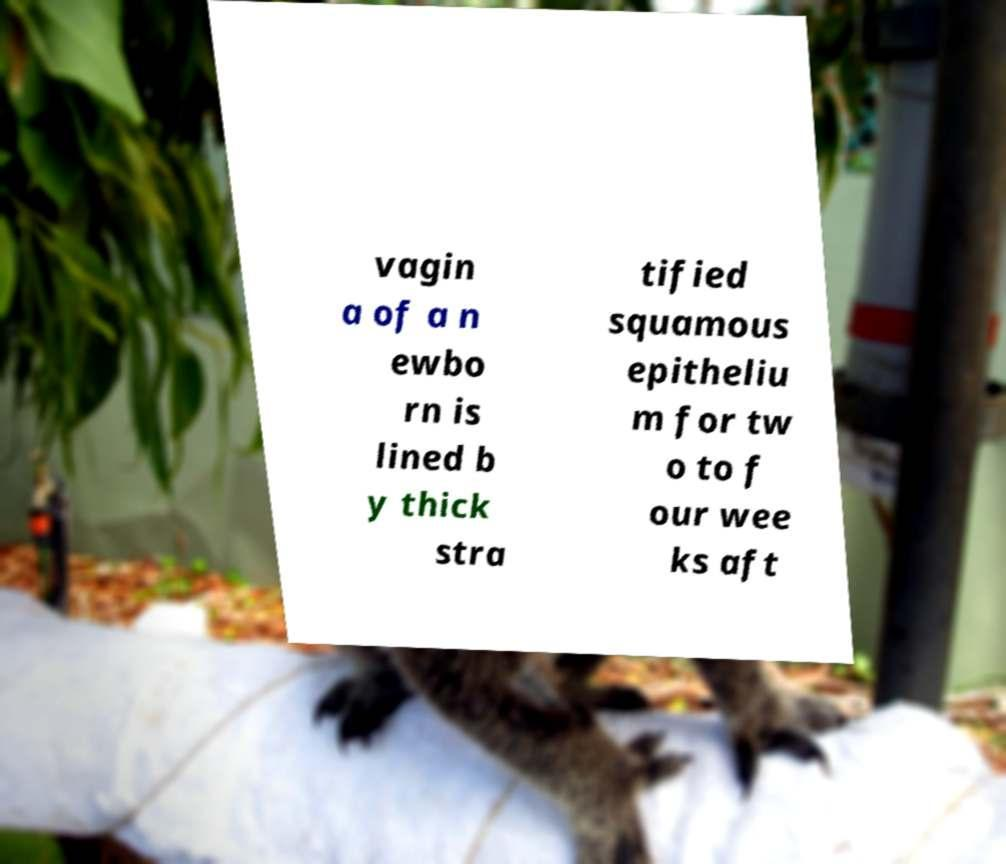Can you read and provide the text displayed in the image?This photo seems to have some interesting text. Can you extract and type it out for me? vagin a of a n ewbo rn is lined b y thick stra tified squamous epitheliu m for tw o to f our wee ks aft 